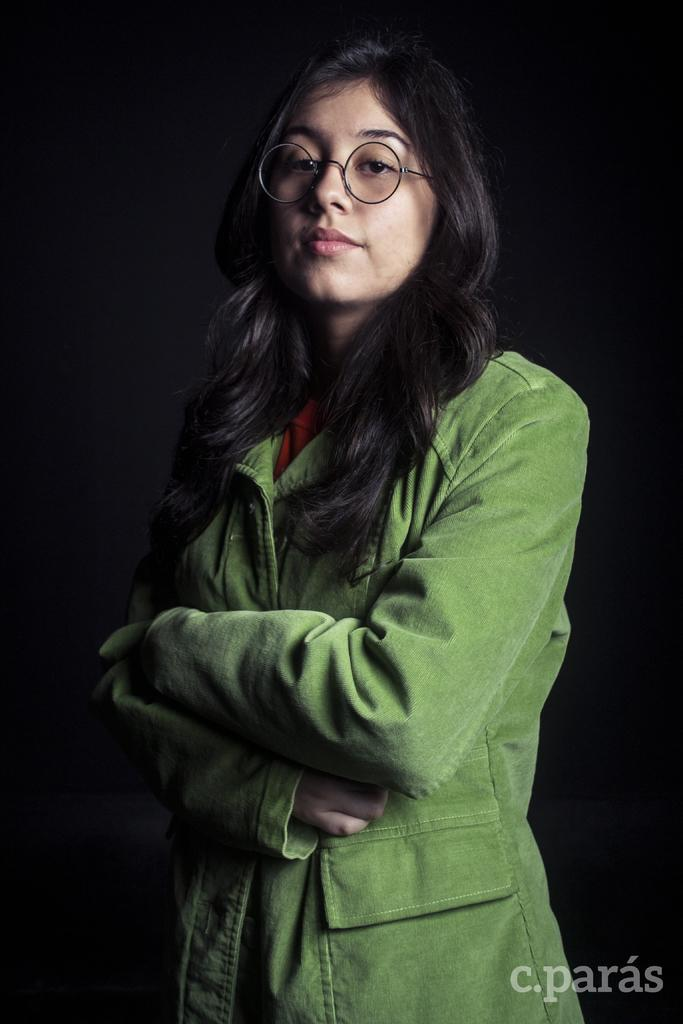Who is present in the image? There is a woman in the image. What is the woman wearing? The woman is wearing a green jacket. What is the woman doing in the image? The woman is standing. What is the color of the background in the image? The background in the image is black. Where is the text located in the image? The text is at the bottom right of the image. How many sticks are being used by the woman in the image? There are no sticks present in the image. What type of car is visible in the background of the image? There is no car visible in the image; the background is black. 